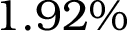<formula> <loc_0><loc_0><loc_500><loc_500>1 . 9 2 \%</formula> 